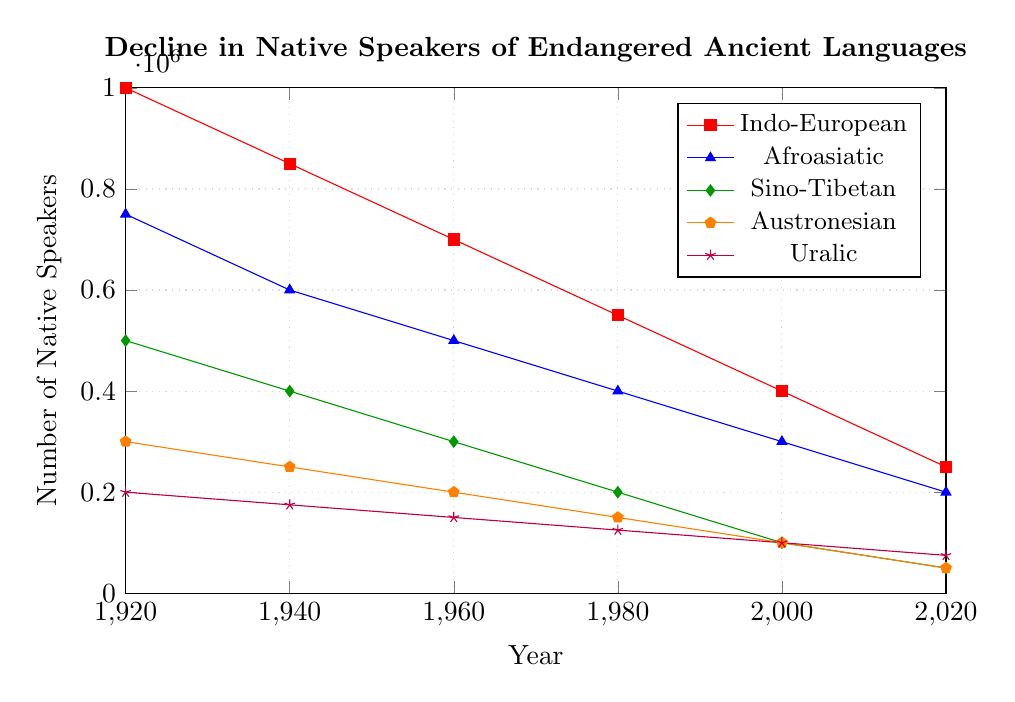What year saw the largest decrease in the number of native speakers for the Indo-European family? To find the largest decrease, look at the differences between consecutive years. The largest drop is between 1920 and 1940, from 1,000,000 to 850,000, a decrease of 150,000.
Answer: 1920-1940 By how much did the number of native speakers of Afroasiatic languages decrease from 1920 to 1960? Subtract the number of native speakers in 1960 from the number in 1920. 750,000 - 500,000 = 250,000.
Answer: 250,000 Which language family had the smallest number of native speakers in the year 2020? Compare the numbers for each language family in 2020. The Sino-Tibetan and Austronesian groups both have 50,000 speakers.
Answer: Sino-Tibetan and Austronesian What is the average number of native speakers for the Uralic language family between 1920 and 2020? Add up the numbers for each year and then divide by the number of years. (200,000 + 175,000 + 150,000 + 125,000 + 100,000 + 75,000) / 6 ≈ 137,500.
Answer: 137,500 Which language family had the least decline in the number of native speakers from 1920 to 2020? Subtract the numbers for 2020 from those for 1920 and find the smallest difference. Uralic: 200,000 - 75,000 = 125,000.
Answer: Uralic How many more native speakers were there for the Indo-European family compared to the Austronesian family in 1940? Subtract the number for Austronesian from the number for Indo-European. 850,000 - 250,000 = 600,000.
Answer: 600,000 What is the total number of native speakers for Sino-Tibetan and Austronesian languages in 1980? Add the numbers for the two families in 1980. 200,000 + 150,000 = 350,000.
Answer: 350,000 Between which two consecutive decades did the Austronesian family experience the smallest decline in native speakers? Calculate the differences for each period: (1940-1960, 50,000), (1960-1980, 50,000), (1980-2000, 50,000), (2000-2020, 50,000). Each period results in an equal decline, so any decade pair from these has the smallest decline of 50,000.
Answer: 1940-1960, 1960-1980, 1980-2000, 2000-2020 (All equal at 50,000) What is the percentage decrease in the number of native speakers of Sino-Tibetan languages from 1920 to 2020? Calculate the difference and then the percentage. (500,000 - 50,000) / 500,000 * 100 = 90%.
Answer: 90% 